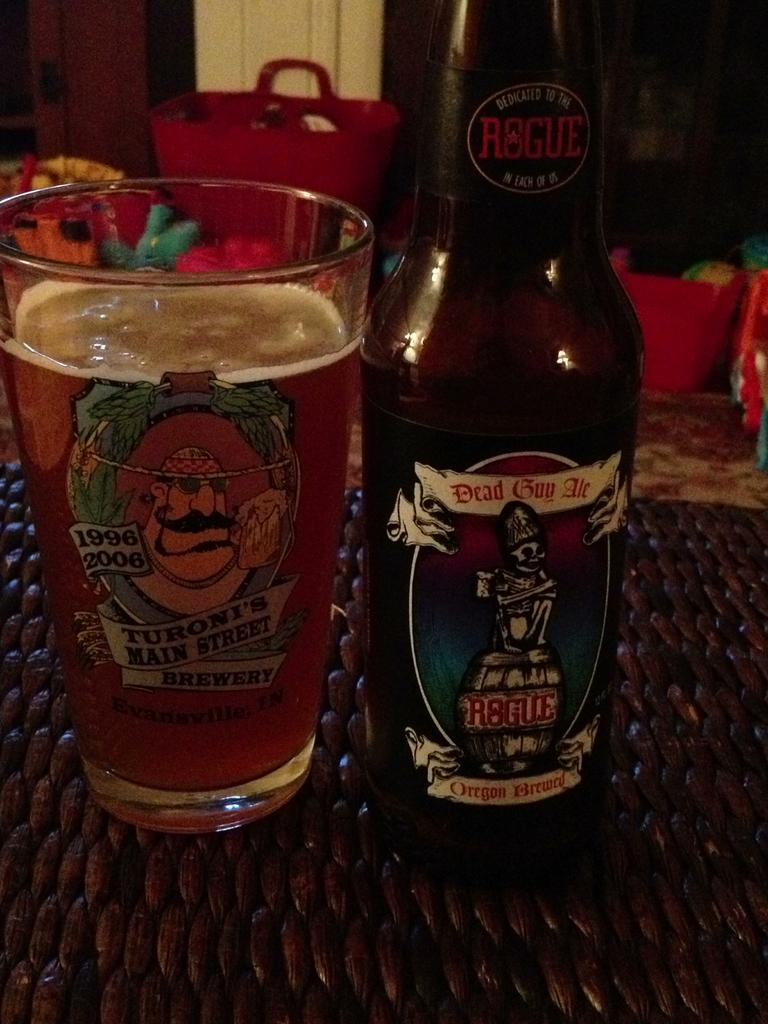<image>
Present a compact description of the photo's key features. A bottle of beer called Dead Guy Me is near a class mug of bear with the text saying "Turoni's Main Street." 